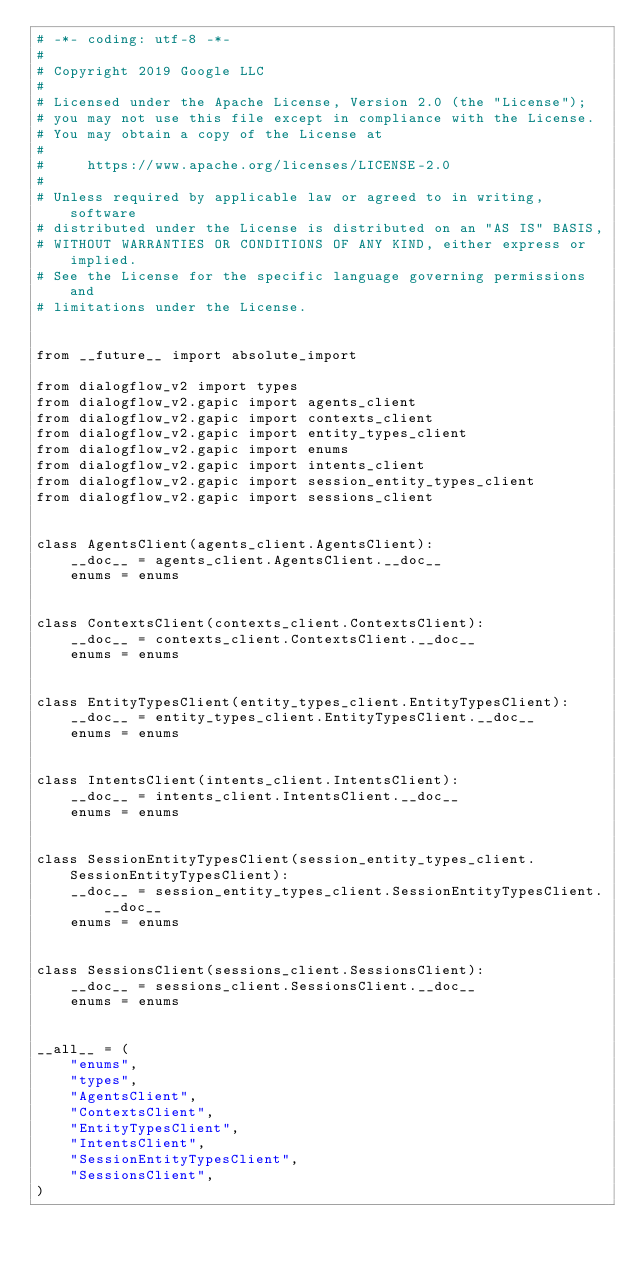Convert code to text. <code><loc_0><loc_0><loc_500><loc_500><_Python_># -*- coding: utf-8 -*-
#
# Copyright 2019 Google LLC
#
# Licensed under the Apache License, Version 2.0 (the "License");
# you may not use this file except in compliance with the License.
# You may obtain a copy of the License at
#
#     https://www.apache.org/licenses/LICENSE-2.0
#
# Unless required by applicable law or agreed to in writing, software
# distributed under the License is distributed on an "AS IS" BASIS,
# WITHOUT WARRANTIES OR CONDITIONS OF ANY KIND, either express or implied.
# See the License for the specific language governing permissions and
# limitations under the License.


from __future__ import absolute_import

from dialogflow_v2 import types
from dialogflow_v2.gapic import agents_client
from dialogflow_v2.gapic import contexts_client
from dialogflow_v2.gapic import entity_types_client
from dialogflow_v2.gapic import enums
from dialogflow_v2.gapic import intents_client
from dialogflow_v2.gapic import session_entity_types_client
from dialogflow_v2.gapic import sessions_client


class AgentsClient(agents_client.AgentsClient):
    __doc__ = agents_client.AgentsClient.__doc__
    enums = enums


class ContextsClient(contexts_client.ContextsClient):
    __doc__ = contexts_client.ContextsClient.__doc__
    enums = enums


class EntityTypesClient(entity_types_client.EntityTypesClient):
    __doc__ = entity_types_client.EntityTypesClient.__doc__
    enums = enums


class IntentsClient(intents_client.IntentsClient):
    __doc__ = intents_client.IntentsClient.__doc__
    enums = enums


class SessionEntityTypesClient(session_entity_types_client.SessionEntityTypesClient):
    __doc__ = session_entity_types_client.SessionEntityTypesClient.__doc__
    enums = enums


class SessionsClient(sessions_client.SessionsClient):
    __doc__ = sessions_client.SessionsClient.__doc__
    enums = enums


__all__ = (
    "enums",
    "types",
    "AgentsClient",
    "ContextsClient",
    "EntityTypesClient",
    "IntentsClient",
    "SessionEntityTypesClient",
    "SessionsClient",
)
</code> 